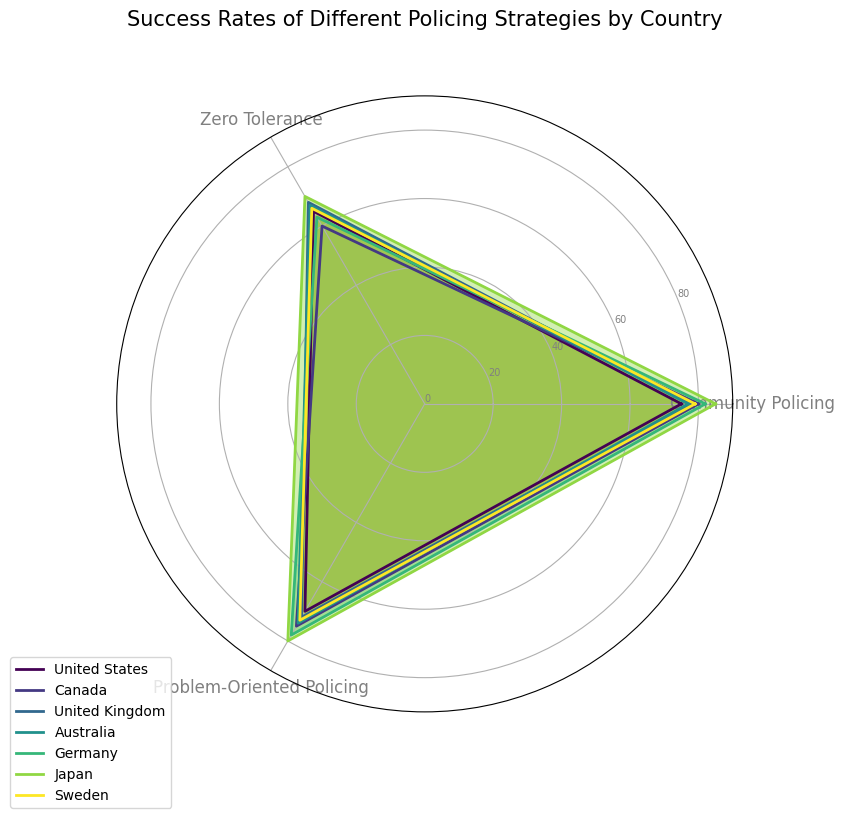What's the highest success rate for community policing and which country does it belong to? By examining the lengths of the radial segments corresponding to community policing, the longest one is for Japan. The value is 85%.
Answer: Japan with 85% Which country has the lowest success rate for zero-tolerance policing? By comparing the radial segments for zero-tolerance policing, the shortest segment belongs to Canada with a success rate of 60%.
Answer: Canada How does the success rate of problem-oriented policing in the United Kingdom compare to that in the United States? Examine the radial segments for problem-oriented policing. The United Kingdom has a success rate of 72%, while the United States has a rate of 70%. The UK has a slightly higher success rate.
Answer: The United Kingdom has a higher success rate of 72% compared to the United States' 70% What is the average success rate of community policing across all countries? The success rates for community policing are: 75% (USA), 80% (Canada), 78% (UK), 77% (Australia), 82% (Germany), 85% (Japan), and 79% (Sweden). Adding them gives 556%. Dividing by 7 (number of countries) results in an average of approximately 79.43%.
Answer: Approximately 79.43% Is the success rate of community policing in Germany higher than the success rate of problem-oriented policing in the United Kingdom? The community policing success rate in Germany is 82%, while the problem-oriented policing success rate in the United Kingdom is 72%. 82% is higher than 72%.
Answer: Yes Which country has the most balanced success rates across all three strategies? A country with similar radial lengths for all three strategies would be balanced. Germany, with rates 82% (Community Policing), 63% (Zero Tolerance), and 78% (Problem-Oriented Policing), seems the most balanced compared to others.
Answer: Germany What is the difference in success rate between community policing and zero-tolerance policing in Australia? The success rate for community policing in Australia is 77%, and for zero-tolerance policing, it is 67%. The difference is: 77% - 67% = 10%.
Answer: 10% Which country has the highest average success rate across all policing strategies? Calculate the average success rate for each country by summing their rates and dividing by 3. The country with the highest average will have the highest cumulative success rate.
- USA: (75% + 65% + 70%) / 3 = 70%
- Canada: (80% + 60% + 75%) / 3 ≈ 71.67%
- UK: (78% + 68% + 72%) / 3 ≈ 72.67%
- Australia: (77% + 67% + 74%) / 3 ≈ 72.67%
- Germany: (82% + 63% + 78%) / 3 ≈ 74.33%
- Japan: (85% + 70% + 80%) / 3 ≈ 78.33%
- Sweden: (79% + 66% + 73%) / 3 ≈ 72.67%
Japan has the highest average of approximately 78.33%.
Answer: Japan What is the difference between the highest and lowest success rates for all countries combined? The highest success rate is for community policing in Japan (85%), and the lowest is for zero-tolerance policing in Canada (60%). The difference is: 85% - 60% = 25%.
Answer: 25% 